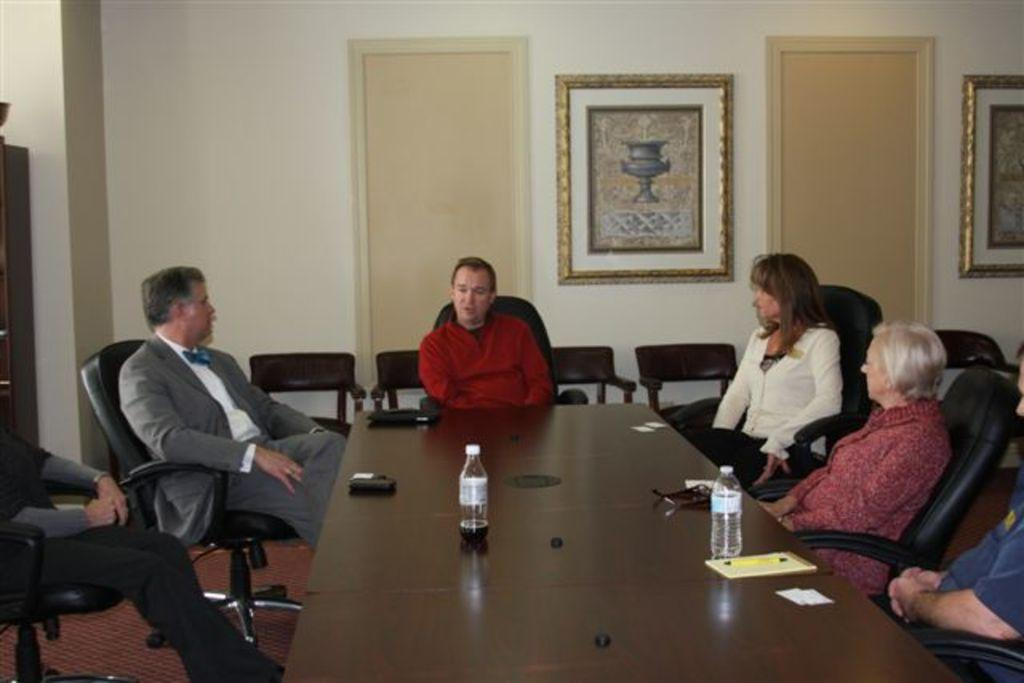What are the people in the image doing? The people are sitting on chairs at a table and talking. How many chairs are visible in the image? There are chairs at the table where the people are sitting, and there are also chairs in the background. What can be seen in the background of the image? In the background, there are doors and frames on the wall. What type of plastic material is being used by the people in the image? There is no mention of plastic material being used by the people in the image. Is there a playground visible in the image? No, there is no playground visible in the image. 